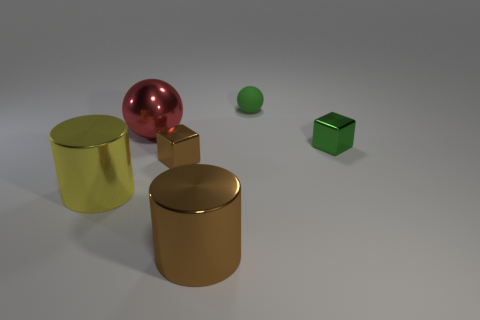Add 1 small rubber spheres. How many objects exist? 7 Subtract all blocks. How many objects are left? 4 Subtract all large yellow shiny cylinders. Subtract all big yellow metal objects. How many objects are left? 4 Add 6 brown things. How many brown things are left? 8 Add 4 tiny metal cubes. How many tiny metal cubes exist? 6 Subtract 0 red cylinders. How many objects are left? 6 